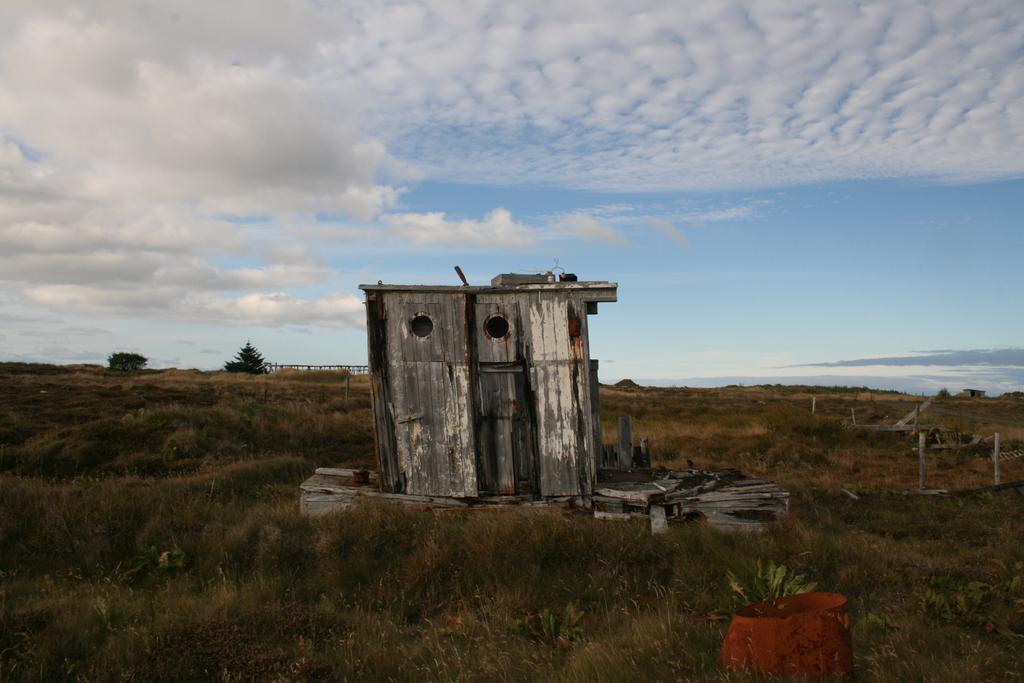Please provide a concise description of this image. In the center of the image we can see the sky, clouds, trees, grass, plants, poles, one wooden house, one brown color object, fence and a few other objects. 